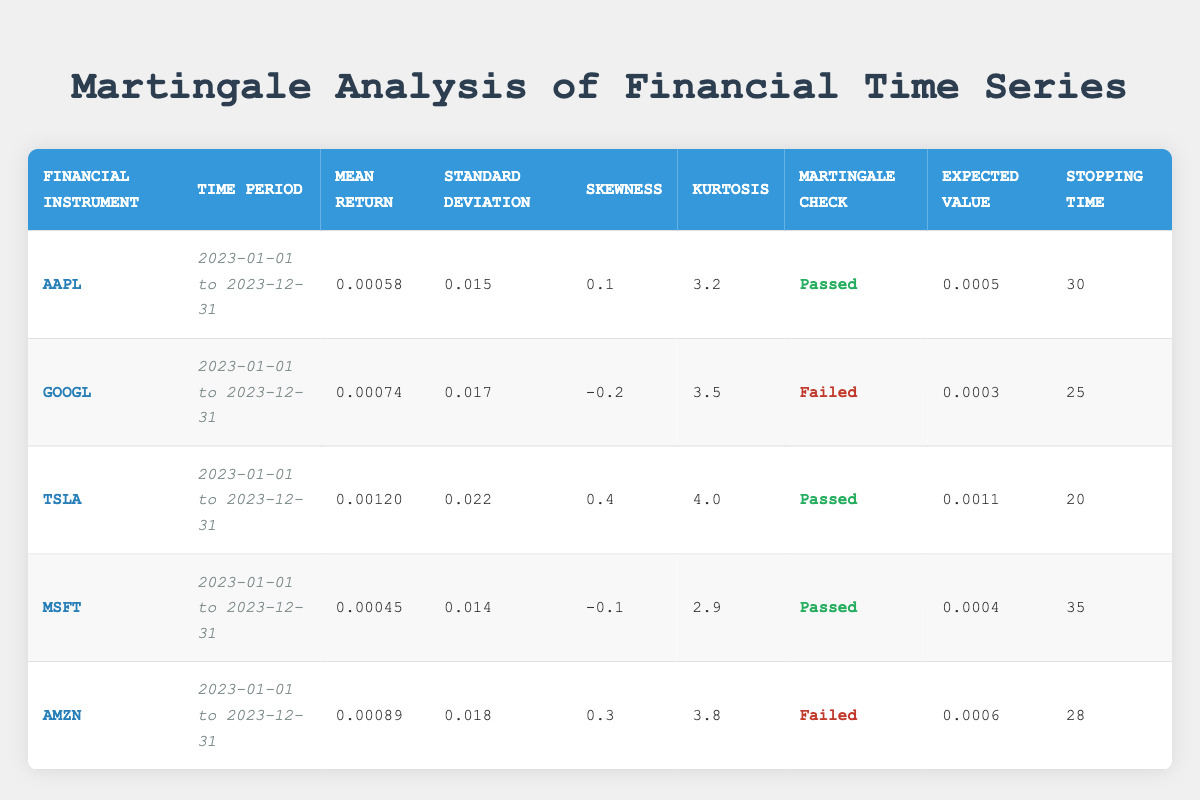What is the mean return for AAPL? The mean return for AAPL can be directly found in the table under the DailyReturns column for AAPL. The value listed is 0.00058.
Answer: 0.00058 Which financial instrument has the highest standard deviation of daily returns? By comparing the Standard Deviation values for each instrument in the table, TSLA has the highest value of 0.022.
Answer: TSLA Did GOOGL pass the martingale check? Looking at the Martingale Check column for GOOGL, it is marked as "Failed."
Answer: No What is the average stopping time for the financial instruments that passed the martingale check? The stopping times for the instruments that passed the martingale check are 30 (AAPL), 20 (TSLA), and 35 (MSFT). Summing these values gives 30 + 20 + 35 = 85. There are three instruments, so the average is 85 / 3 = 28.33.
Answer: 28.33 How many instruments have a mean return greater than 0.0007? Looking at the Mean Return figures for each instrument, both GOOGL (0.00074) and AMZN (0.00089) exceed 0.0007. Thus, there are two instruments.
Answer: 2 What is the skewness of the financial instrument with the lowest mean return? The instrument with the lowest mean return is MSFT, which has a mean return of 0.00045. The skewness for MSFT is listed as -0.1.
Answer: -0.1 Is there any instrument with a stopping time greater than 30? The stopping times are compared: AAPL (30), GOOGL (25), TSLA (20), MSFT (35), and AMZN (28). MSFT has a stopping time of 35, which is greater than 30.
Answer: Yes What is the difference in expected value between TSLA and AAPL? The expected value for TSLA is 0.0011 and for AAPL is 0.0005. To find the difference, we subtract: 0.0011 - 0.0005 = 0.0006.
Answer: 0.0006 